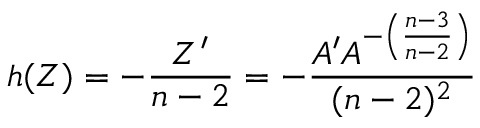Convert formula to latex. <formula><loc_0><loc_0><loc_500><loc_500>h ( Z ) = - \frac { Z ^ { \prime } } { n - 2 } = - \frac { A ^ { \prime } A ^ { - \left ( \frac { n - 3 } { n - 2 } \right ) } } { ( n - 2 ) ^ { 2 } }</formula> 